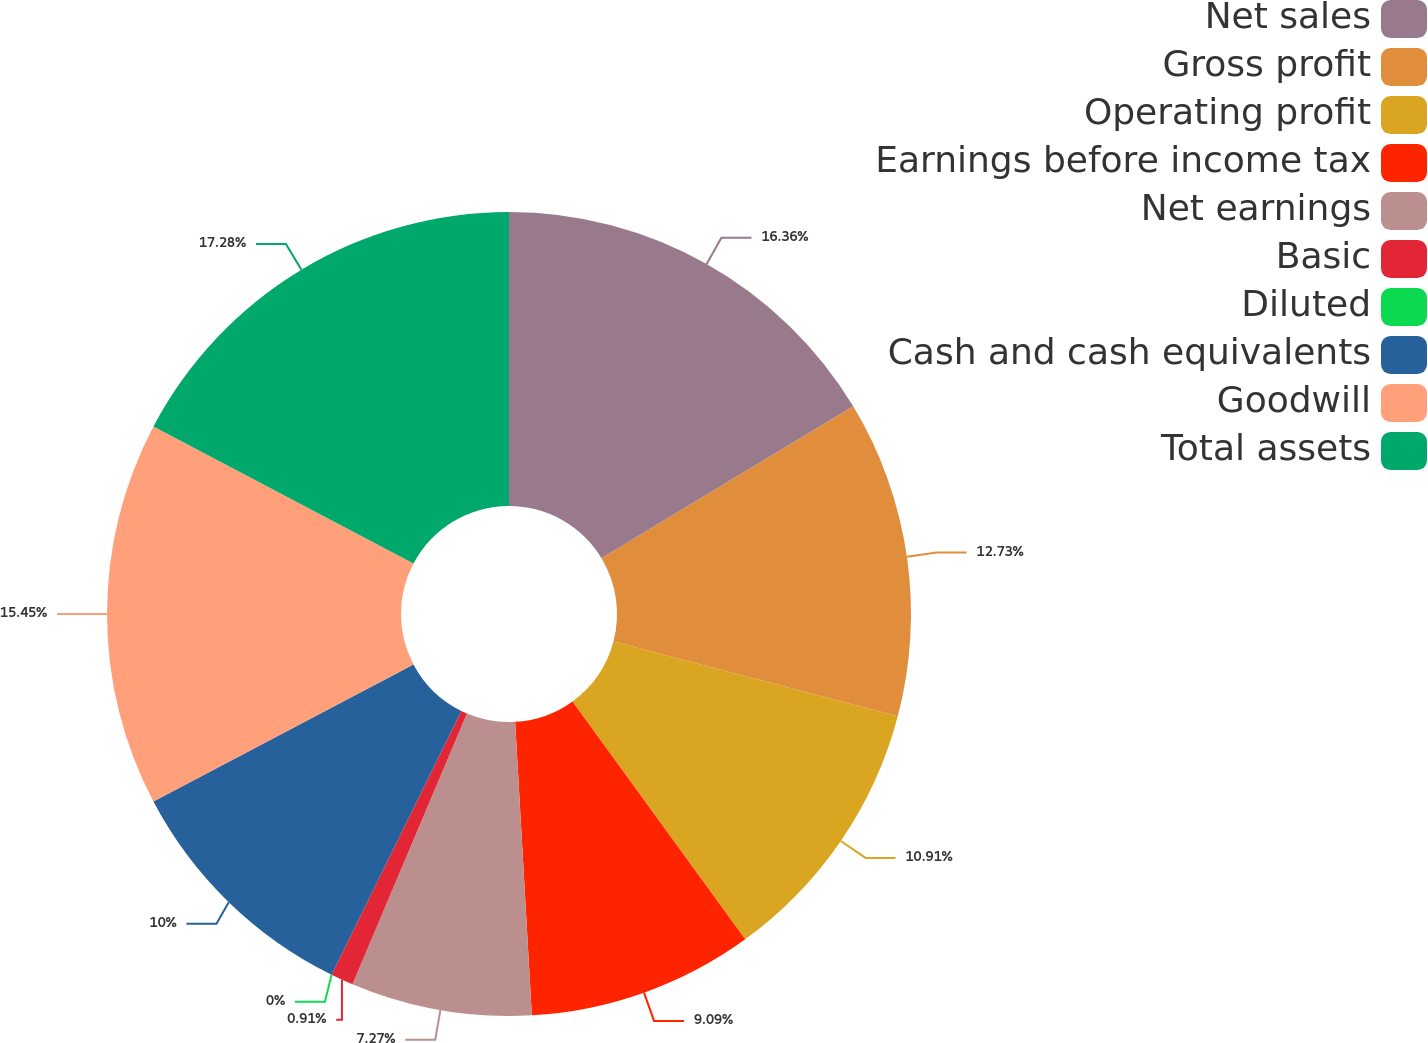<chart> <loc_0><loc_0><loc_500><loc_500><pie_chart><fcel>Net sales<fcel>Gross profit<fcel>Operating profit<fcel>Earnings before income tax<fcel>Net earnings<fcel>Basic<fcel>Diluted<fcel>Cash and cash equivalents<fcel>Goodwill<fcel>Total assets<nl><fcel>16.36%<fcel>12.73%<fcel>10.91%<fcel>9.09%<fcel>7.27%<fcel>0.91%<fcel>0.0%<fcel>10.0%<fcel>15.45%<fcel>17.27%<nl></chart> 